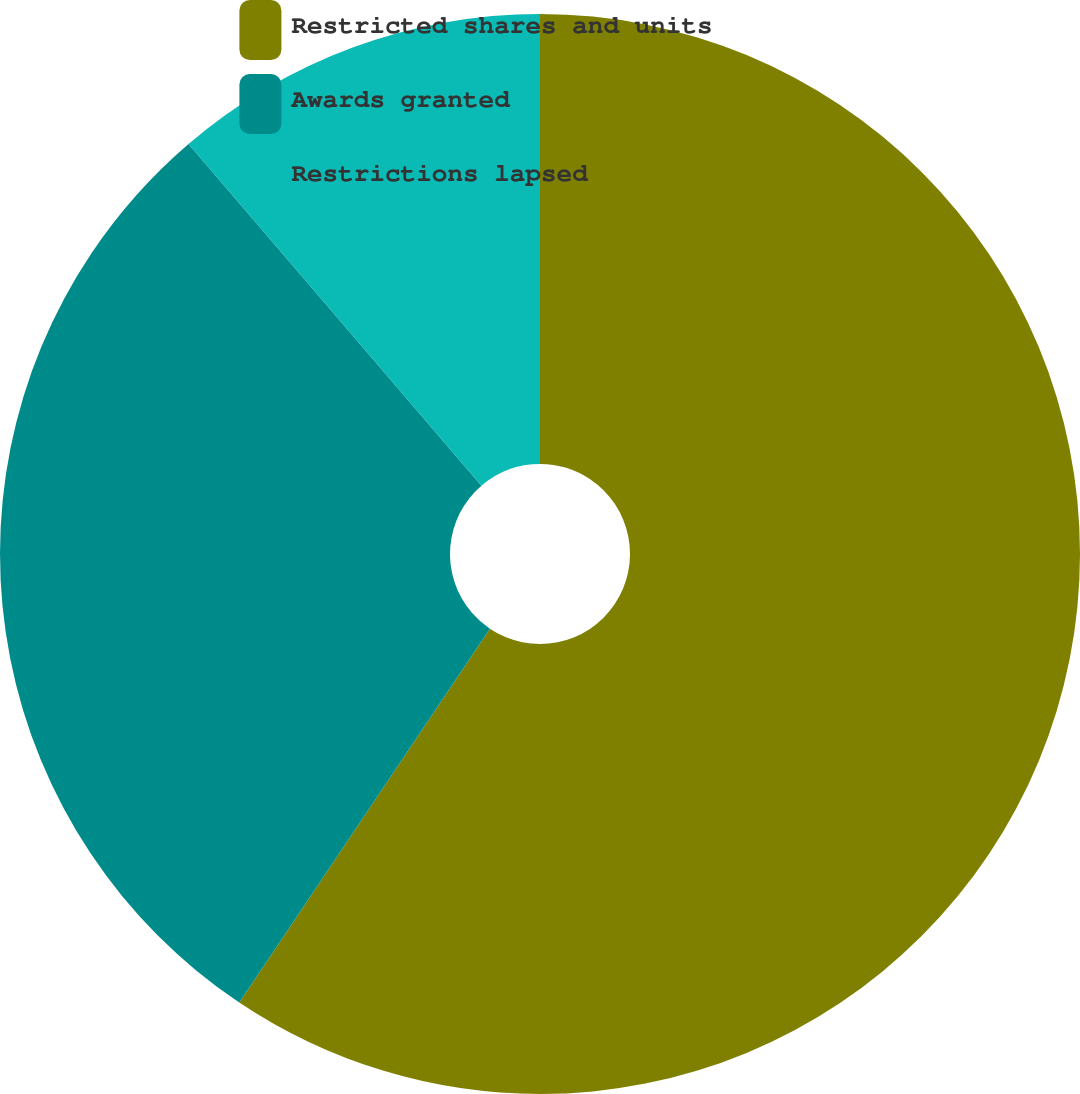Convert chart. <chart><loc_0><loc_0><loc_500><loc_500><pie_chart><fcel>Restricted shares and units<fcel>Awards granted<fcel>Restrictions lapsed<nl><fcel>59.4%<fcel>29.32%<fcel>11.28%<nl></chart> 